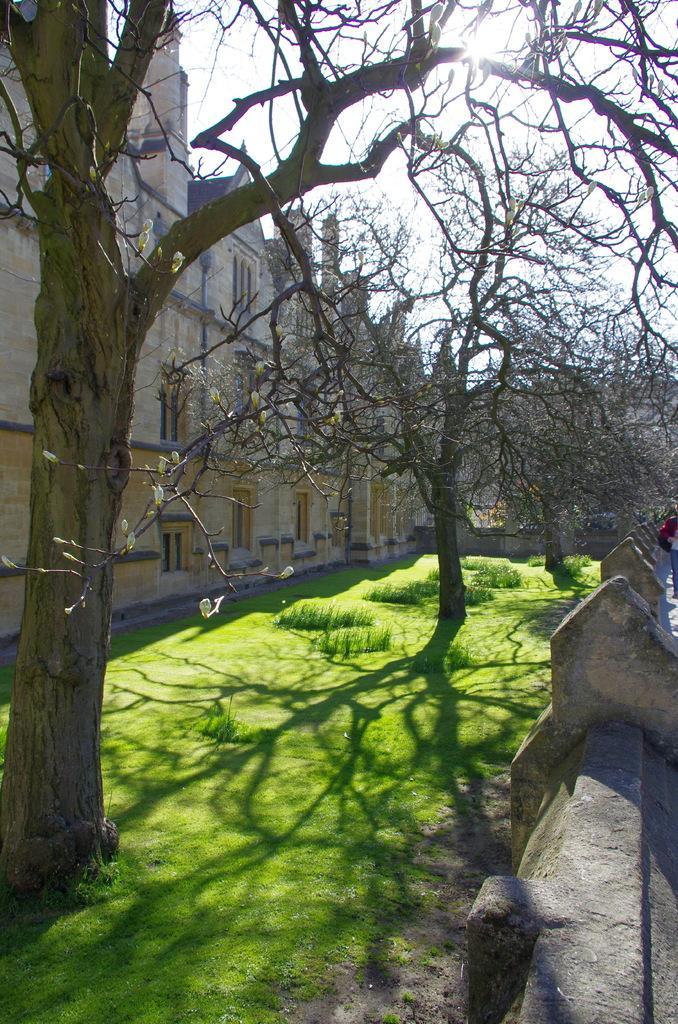Could you give a brief overview of what you see in this image? In this image we can see dry trees on the grassy land. Behind the trees, we can see a building and the sky. There is a boundary wall on the right side of the image and we can see one person. 